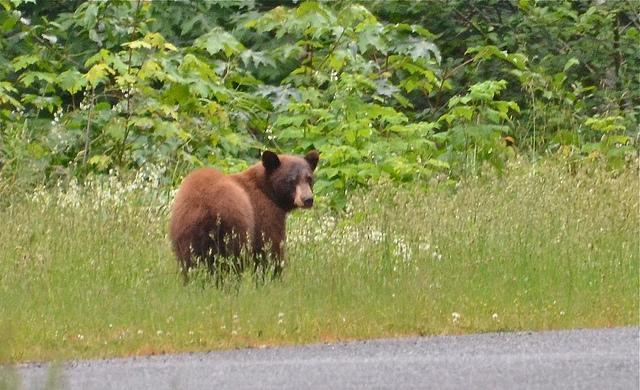Is the bear in the wild?
Write a very short answer. Yes. What color is the bear?
Quick response, please. Brown. What is looking at you?
Short answer required. Bear. 